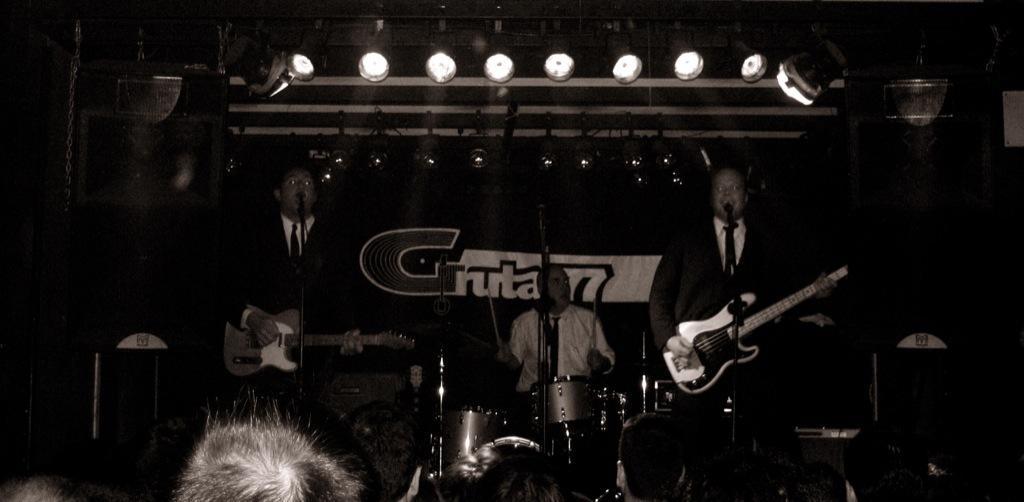Describe this image in one or two sentences. In this image in the front there are persons. In the center there are musicians performing on the stage holding musical instruments in their hands and on the top there are lights. In the background there is a banner with some text written on it and in front of the banner there is a person holding sticks in his hand and in front of the person there is a musical drum. 